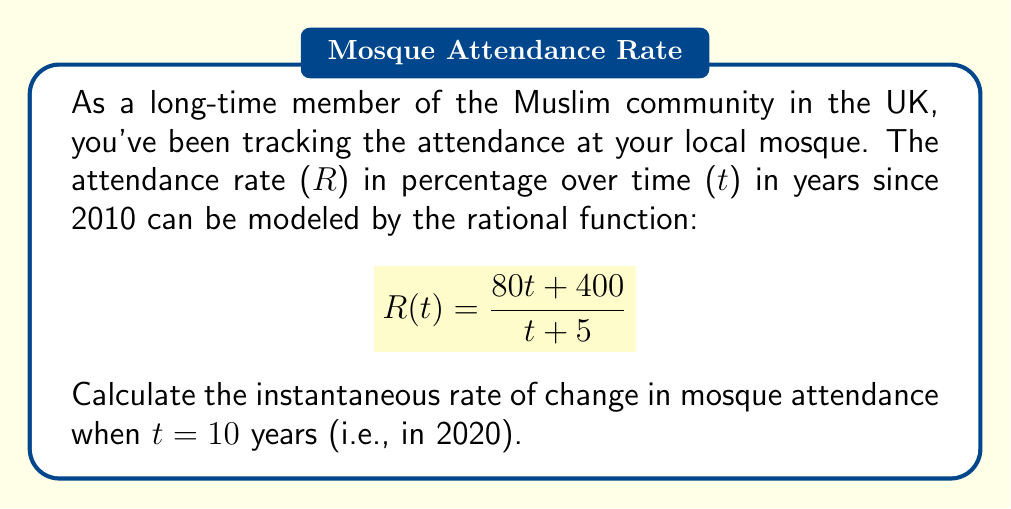Show me your answer to this math problem. To find the instantaneous rate of change at t = 10, we need to calculate the derivative of R(t) and then evaluate it at t = 10.

Step 1: Calculate the derivative of R(t) using the quotient rule.
Let $u = 80t + 400$ and $v = t + 5$

$$R'(t) = \frac{u'v - uv'}{v^2}$$

Where $u' = 80$ and $v' = 1$

$$R'(t) = \frac{80(t+5) - (80t+400)(1)}{(t+5)^2}$$

Step 2: Simplify the numerator
$$R'(t) = \frac{80t + 400 - 80t - 400}{(t+5)^2}$$
$$R'(t) = \frac{0}{(t+5)^2}$$

Step 3: Evaluate R'(t) at t = 10
$$R'(10) = \frac{0}{(10+5)^2} = \frac{0}{225} = 0$$

Therefore, the instantaneous rate of change in mosque attendance when t = 10 years (in 2020) is 0% per year.
Answer: 0% per year 